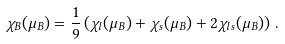Convert formula to latex. <formula><loc_0><loc_0><loc_500><loc_500>\chi _ { B } ( \mu _ { B } ) = \frac { 1 } { 9 } \left ( \chi _ { l } ( \mu _ { B } ) + \chi _ { s } ( \mu _ { B } ) + 2 \chi _ { l s } ( \mu _ { B } ) \right ) \, .</formula> 